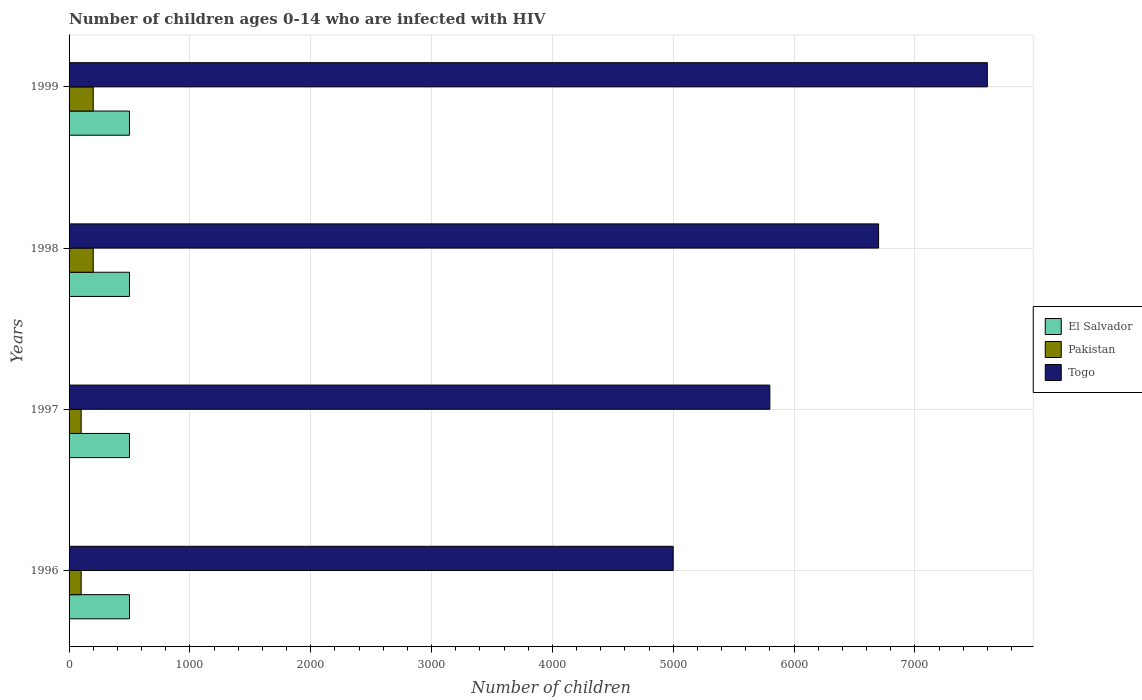How many groups of bars are there?
Provide a short and direct response. 4. How many bars are there on the 1st tick from the bottom?
Ensure brevity in your answer.  3. What is the number of HIV infected children in Togo in 1996?
Ensure brevity in your answer.  5000. Across all years, what is the maximum number of HIV infected children in Togo?
Give a very brief answer. 7600. Across all years, what is the minimum number of HIV infected children in Pakistan?
Keep it short and to the point. 100. What is the total number of HIV infected children in Togo in the graph?
Offer a very short reply. 2.51e+04. What is the difference between the number of HIV infected children in El Salvador in 1997 and that in 1999?
Ensure brevity in your answer.  0. What is the difference between the number of HIV infected children in Togo in 1998 and the number of HIV infected children in El Salvador in 1999?
Your answer should be very brief. 6200. What is the average number of HIV infected children in Togo per year?
Ensure brevity in your answer.  6275. In the year 1999, what is the difference between the number of HIV infected children in El Salvador and number of HIV infected children in Pakistan?
Your response must be concise. 300. Is the difference between the number of HIV infected children in El Salvador in 1996 and 1998 greater than the difference between the number of HIV infected children in Pakistan in 1996 and 1998?
Your answer should be very brief. Yes. What is the difference between the highest and the lowest number of HIV infected children in El Salvador?
Your answer should be compact. 0. In how many years, is the number of HIV infected children in Togo greater than the average number of HIV infected children in Togo taken over all years?
Provide a short and direct response. 2. Is the sum of the number of HIV infected children in Pakistan in 1998 and 1999 greater than the maximum number of HIV infected children in Togo across all years?
Ensure brevity in your answer.  No. What does the 3rd bar from the top in 1997 represents?
Offer a terse response. El Salvador. How many bars are there?
Provide a succinct answer. 12. What is the difference between two consecutive major ticks on the X-axis?
Offer a very short reply. 1000. Does the graph contain any zero values?
Keep it short and to the point. No. How are the legend labels stacked?
Offer a very short reply. Vertical. What is the title of the graph?
Keep it short and to the point. Number of children ages 0-14 who are infected with HIV. What is the label or title of the X-axis?
Offer a terse response. Number of children. What is the label or title of the Y-axis?
Offer a very short reply. Years. What is the Number of children in El Salvador in 1996?
Provide a short and direct response. 500. What is the Number of children of Pakistan in 1997?
Make the answer very short. 100. What is the Number of children of Togo in 1997?
Your answer should be very brief. 5800. What is the Number of children in El Salvador in 1998?
Offer a terse response. 500. What is the Number of children in Togo in 1998?
Give a very brief answer. 6700. What is the Number of children of El Salvador in 1999?
Give a very brief answer. 500. What is the Number of children in Togo in 1999?
Ensure brevity in your answer.  7600. Across all years, what is the maximum Number of children in Pakistan?
Your answer should be very brief. 200. Across all years, what is the maximum Number of children of Togo?
Provide a short and direct response. 7600. Across all years, what is the minimum Number of children in Pakistan?
Your answer should be compact. 100. What is the total Number of children of Pakistan in the graph?
Offer a terse response. 600. What is the total Number of children of Togo in the graph?
Offer a terse response. 2.51e+04. What is the difference between the Number of children of El Salvador in 1996 and that in 1997?
Provide a short and direct response. 0. What is the difference between the Number of children in Pakistan in 1996 and that in 1997?
Your response must be concise. 0. What is the difference between the Number of children of Togo in 1996 and that in 1997?
Ensure brevity in your answer.  -800. What is the difference between the Number of children of El Salvador in 1996 and that in 1998?
Keep it short and to the point. 0. What is the difference between the Number of children in Pakistan in 1996 and that in 1998?
Ensure brevity in your answer.  -100. What is the difference between the Number of children in Togo in 1996 and that in 1998?
Ensure brevity in your answer.  -1700. What is the difference between the Number of children of El Salvador in 1996 and that in 1999?
Offer a very short reply. 0. What is the difference between the Number of children in Pakistan in 1996 and that in 1999?
Offer a terse response. -100. What is the difference between the Number of children in Togo in 1996 and that in 1999?
Keep it short and to the point. -2600. What is the difference between the Number of children of Pakistan in 1997 and that in 1998?
Your answer should be compact. -100. What is the difference between the Number of children of Togo in 1997 and that in 1998?
Provide a short and direct response. -900. What is the difference between the Number of children in El Salvador in 1997 and that in 1999?
Make the answer very short. 0. What is the difference between the Number of children of Pakistan in 1997 and that in 1999?
Provide a succinct answer. -100. What is the difference between the Number of children in Togo in 1997 and that in 1999?
Make the answer very short. -1800. What is the difference between the Number of children of El Salvador in 1998 and that in 1999?
Give a very brief answer. 0. What is the difference between the Number of children in Pakistan in 1998 and that in 1999?
Ensure brevity in your answer.  0. What is the difference between the Number of children of Togo in 1998 and that in 1999?
Give a very brief answer. -900. What is the difference between the Number of children in El Salvador in 1996 and the Number of children in Pakistan in 1997?
Your answer should be compact. 400. What is the difference between the Number of children of El Salvador in 1996 and the Number of children of Togo in 1997?
Keep it short and to the point. -5300. What is the difference between the Number of children of Pakistan in 1996 and the Number of children of Togo in 1997?
Offer a terse response. -5700. What is the difference between the Number of children of El Salvador in 1996 and the Number of children of Pakistan in 1998?
Your answer should be very brief. 300. What is the difference between the Number of children in El Salvador in 1996 and the Number of children in Togo in 1998?
Provide a short and direct response. -6200. What is the difference between the Number of children in Pakistan in 1996 and the Number of children in Togo in 1998?
Your answer should be very brief. -6600. What is the difference between the Number of children in El Salvador in 1996 and the Number of children in Pakistan in 1999?
Your answer should be very brief. 300. What is the difference between the Number of children of El Salvador in 1996 and the Number of children of Togo in 1999?
Provide a short and direct response. -7100. What is the difference between the Number of children of Pakistan in 1996 and the Number of children of Togo in 1999?
Offer a very short reply. -7500. What is the difference between the Number of children in El Salvador in 1997 and the Number of children in Pakistan in 1998?
Make the answer very short. 300. What is the difference between the Number of children in El Salvador in 1997 and the Number of children in Togo in 1998?
Offer a very short reply. -6200. What is the difference between the Number of children in Pakistan in 1997 and the Number of children in Togo in 1998?
Give a very brief answer. -6600. What is the difference between the Number of children in El Salvador in 1997 and the Number of children in Pakistan in 1999?
Your response must be concise. 300. What is the difference between the Number of children of El Salvador in 1997 and the Number of children of Togo in 1999?
Provide a succinct answer. -7100. What is the difference between the Number of children in Pakistan in 1997 and the Number of children in Togo in 1999?
Make the answer very short. -7500. What is the difference between the Number of children in El Salvador in 1998 and the Number of children in Pakistan in 1999?
Offer a terse response. 300. What is the difference between the Number of children in El Salvador in 1998 and the Number of children in Togo in 1999?
Your answer should be compact. -7100. What is the difference between the Number of children of Pakistan in 1998 and the Number of children of Togo in 1999?
Your answer should be very brief. -7400. What is the average Number of children of El Salvador per year?
Provide a short and direct response. 500. What is the average Number of children of Pakistan per year?
Offer a very short reply. 150. What is the average Number of children in Togo per year?
Provide a succinct answer. 6275. In the year 1996, what is the difference between the Number of children in El Salvador and Number of children in Togo?
Your answer should be very brief. -4500. In the year 1996, what is the difference between the Number of children in Pakistan and Number of children in Togo?
Your answer should be compact. -4900. In the year 1997, what is the difference between the Number of children of El Salvador and Number of children of Togo?
Your response must be concise. -5300. In the year 1997, what is the difference between the Number of children of Pakistan and Number of children of Togo?
Provide a succinct answer. -5700. In the year 1998, what is the difference between the Number of children of El Salvador and Number of children of Pakistan?
Keep it short and to the point. 300. In the year 1998, what is the difference between the Number of children in El Salvador and Number of children in Togo?
Your response must be concise. -6200. In the year 1998, what is the difference between the Number of children of Pakistan and Number of children of Togo?
Give a very brief answer. -6500. In the year 1999, what is the difference between the Number of children of El Salvador and Number of children of Pakistan?
Ensure brevity in your answer.  300. In the year 1999, what is the difference between the Number of children in El Salvador and Number of children in Togo?
Make the answer very short. -7100. In the year 1999, what is the difference between the Number of children in Pakistan and Number of children in Togo?
Ensure brevity in your answer.  -7400. What is the ratio of the Number of children in El Salvador in 1996 to that in 1997?
Your answer should be very brief. 1. What is the ratio of the Number of children of Togo in 1996 to that in 1997?
Your answer should be compact. 0.86. What is the ratio of the Number of children of El Salvador in 1996 to that in 1998?
Keep it short and to the point. 1. What is the ratio of the Number of children of Pakistan in 1996 to that in 1998?
Provide a succinct answer. 0.5. What is the ratio of the Number of children of Togo in 1996 to that in 1998?
Keep it short and to the point. 0.75. What is the ratio of the Number of children of El Salvador in 1996 to that in 1999?
Offer a terse response. 1. What is the ratio of the Number of children in Pakistan in 1996 to that in 1999?
Your response must be concise. 0.5. What is the ratio of the Number of children of Togo in 1996 to that in 1999?
Keep it short and to the point. 0.66. What is the ratio of the Number of children in Pakistan in 1997 to that in 1998?
Offer a terse response. 0.5. What is the ratio of the Number of children of Togo in 1997 to that in 1998?
Provide a succinct answer. 0.87. What is the ratio of the Number of children in Pakistan in 1997 to that in 1999?
Your answer should be compact. 0.5. What is the ratio of the Number of children in Togo in 1997 to that in 1999?
Offer a terse response. 0.76. What is the ratio of the Number of children in El Salvador in 1998 to that in 1999?
Ensure brevity in your answer.  1. What is the ratio of the Number of children in Pakistan in 1998 to that in 1999?
Make the answer very short. 1. What is the ratio of the Number of children in Togo in 1998 to that in 1999?
Provide a short and direct response. 0.88. What is the difference between the highest and the second highest Number of children in Pakistan?
Provide a succinct answer. 0. What is the difference between the highest and the second highest Number of children of Togo?
Keep it short and to the point. 900. What is the difference between the highest and the lowest Number of children of Pakistan?
Make the answer very short. 100. What is the difference between the highest and the lowest Number of children of Togo?
Your response must be concise. 2600. 